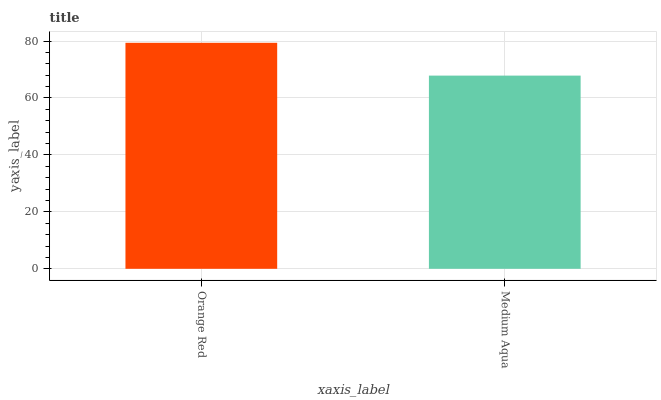Is Medium Aqua the minimum?
Answer yes or no. Yes. Is Orange Red the maximum?
Answer yes or no. Yes. Is Medium Aqua the maximum?
Answer yes or no. No. Is Orange Red greater than Medium Aqua?
Answer yes or no. Yes. Is Medium Aqua less than Orange Red?
Answer yes or no. Yes. Is Medium Aqua greater than Orange Red?
Answer yes or no. No. Is Orange Red less than Medium Aqua?
Answer yes or no. No. Is Orange Red the high median?
Answer yes or no. Yes. Is Medium Aqua the low median?
Answer yes or no. Yes. Is Medium Aqua the high median?
Answer yes or no. No. Is Orange Red the low median?
Answer yes or no. No. 